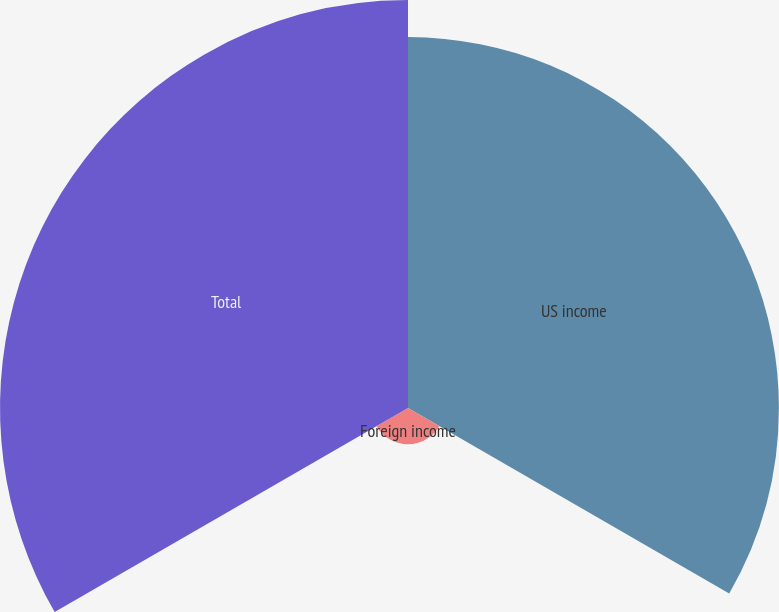<chart> <loc_0><loc_0><loc_500><loc_500><pie_chart><fcel>US income<fcel>Foreign income<fcel>Total<nl><fcel>45.5%<fcel>4.45%<fcel>50.05%<nl></chart> 